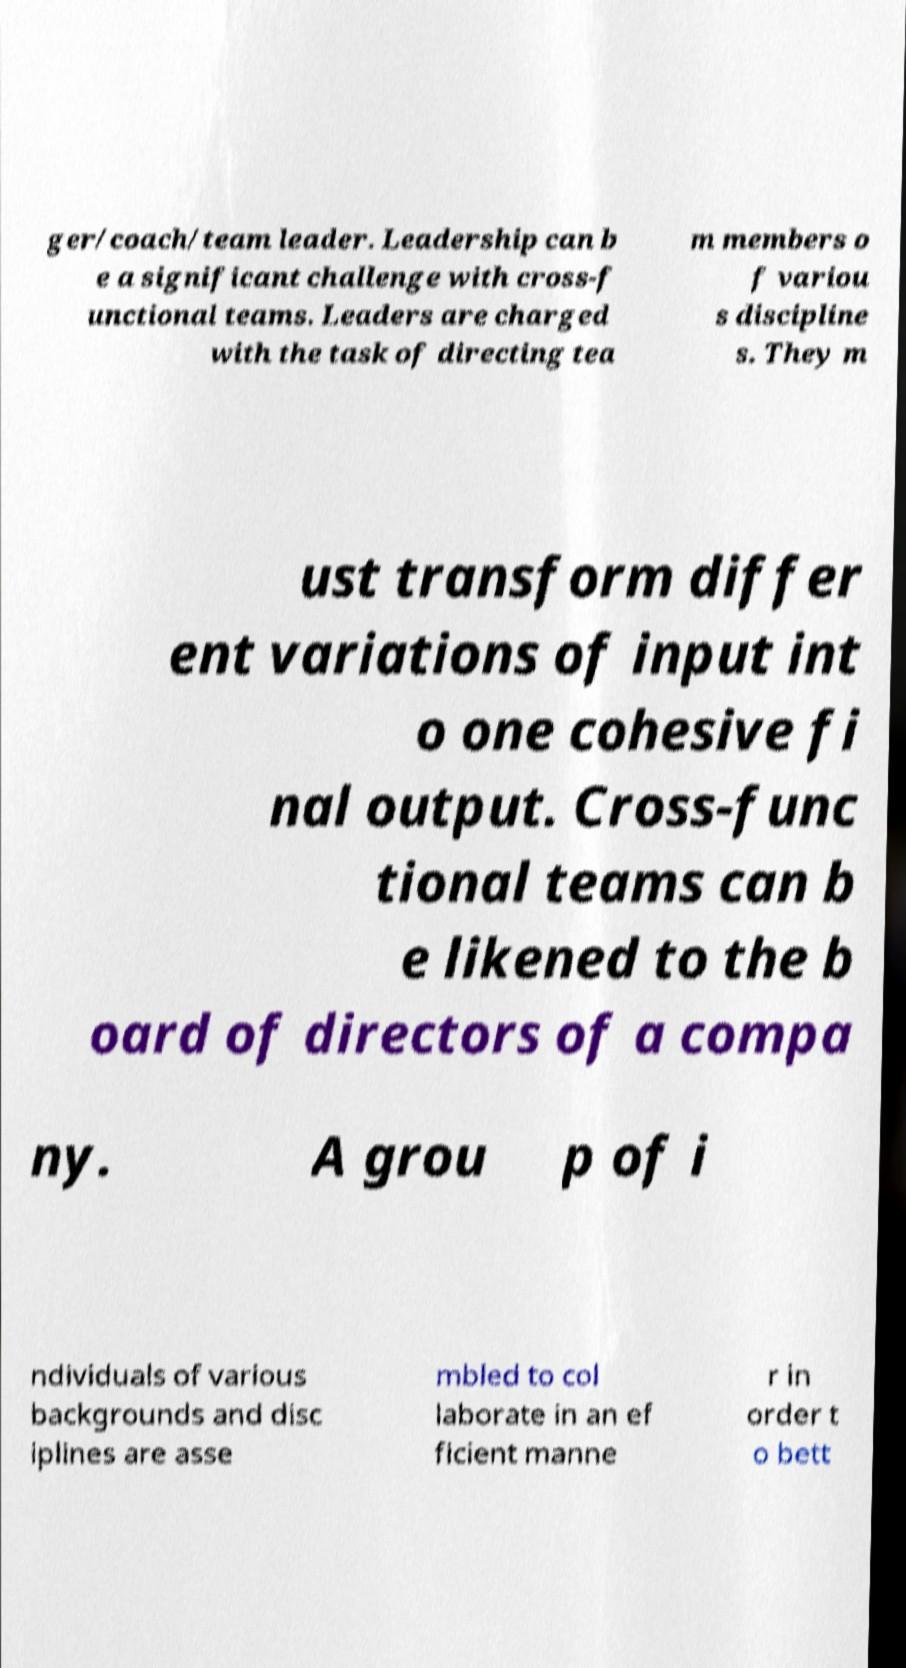Could you extract and type out the text from this image? ger/coach/team leader. Leadership can b e a significant challenge with cross-f unctional teams. Leaders are charged with the task of directing tea m members o f variou s discipline s. They m ust transform differ ent variations of input int o one cohesive fi nal output. Cross-func tional teams can b e likened to the b oard of directors of a compa ny. A grou p of i ndividuals of various backgrounds and disc iplines are asse mbled to col laborate in an ef ficient manne r in order t o bett 